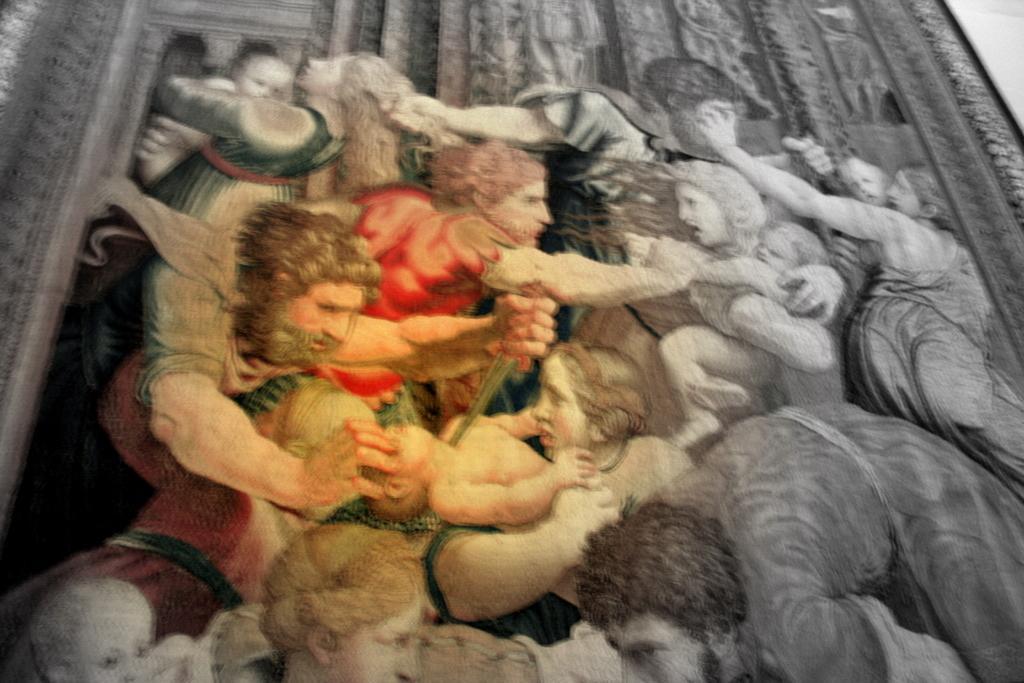In one or two sentences, can you explain what this image depicts? In this black and white picture there is a picture frame on the wall. There are paintings of people on the frame. In the center there is a colored print on the frame. 